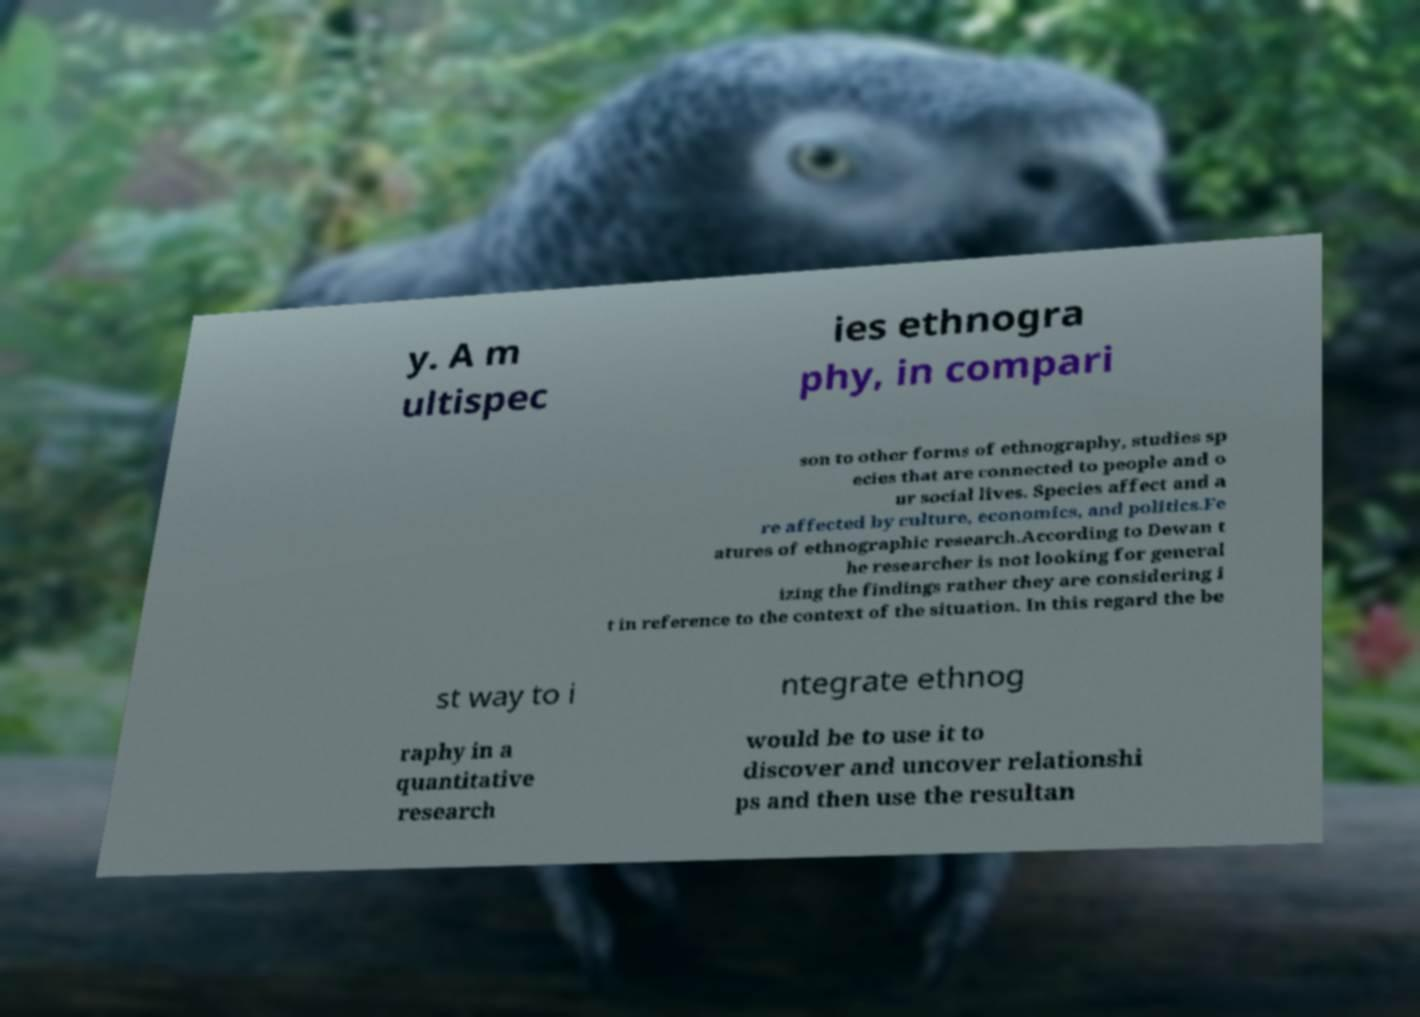I need the written content from this picture converted into text. Can you do that? y. A m ultispec ies ethnogra phy, in compari son to other forms of ethnography, studies sp ecies that are connected to people and o ur social lives. Species affect and a re affected by culture, economics, and politics.Fe atures of ethnographic research.According to Dewan t he researcher is not looking for general izing the findings rather they are considering i t in reference to the context of the situation. In this regard the be st way to i ntegrate ethnog raphy in a quantitative research would be to use it to discover and uncover relationshi ps and then use the resultan 